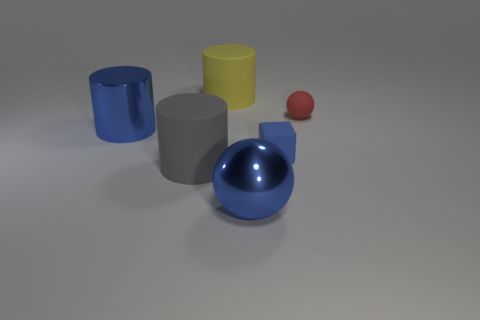Subtract all big blue cylinders. How many cylinders are left? 2 Subtract all balls. How many objects are left? 4 Add 1 tiny brown rubber cubes. How many objects exist? 7 Subtract all blue balls. How many balls are left? 1 Subtract all gray blocks. How many yellow cylinders are left? 1 Subtract all gray metallic cylinders. Subtract all matte cubes. How many objects are left? 5 Add 5 tiny red matte spheres. How many tiny red matte spheres are left? 6 Add 3 large purple metallic spheres. How many large purple metallic spheres exist? 3 Subtract 0 green cylinders. How many objects are left? 6 Subtract 1 blocks. How many blocks are left? 0 